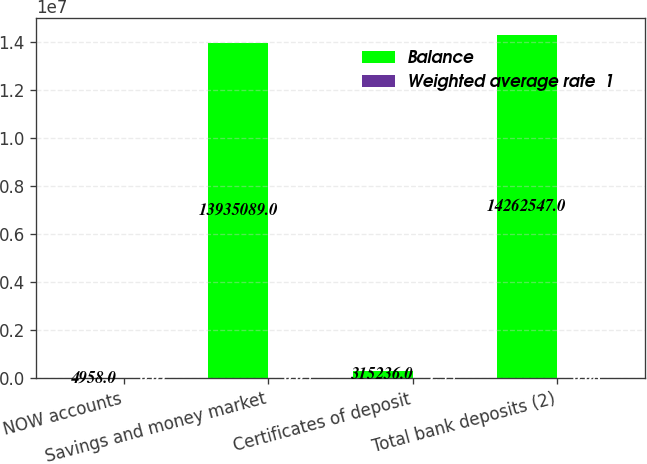<chart> <loc_0><loc_0><loc_500><loc_500><stacked_bar_chart><ecel><fcel>NOW accounts<fcel>Savings and money market<fcel>Certificates of deposit<fcel>Total bank deposits (2)<nl><fcel>Balance<fcel>4958<fcel>1.39351e+07<fcel>315236<fcel>1.42625e+07<nl><fcel>Weighted average rate  1<fcel>0.01<fcel>0.05<fcel>1.55<fcel>0.08<nl></chart> 